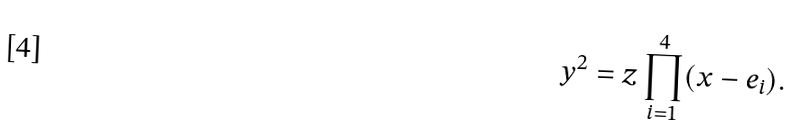<formula> <loc_0><loc_0><loc_500><loc_500>y ^ { 2 } = z \prod _ { i = 1 } ^ { 4 } ( x - e _ { i } ) .</formula> 